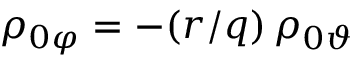<formula> <loc_0><loc_0><loc_500><loc_500>\rho _ { 0 \varphi } = - ( r / q ) \, \rho _ { 0 \vartheta }</formula> 